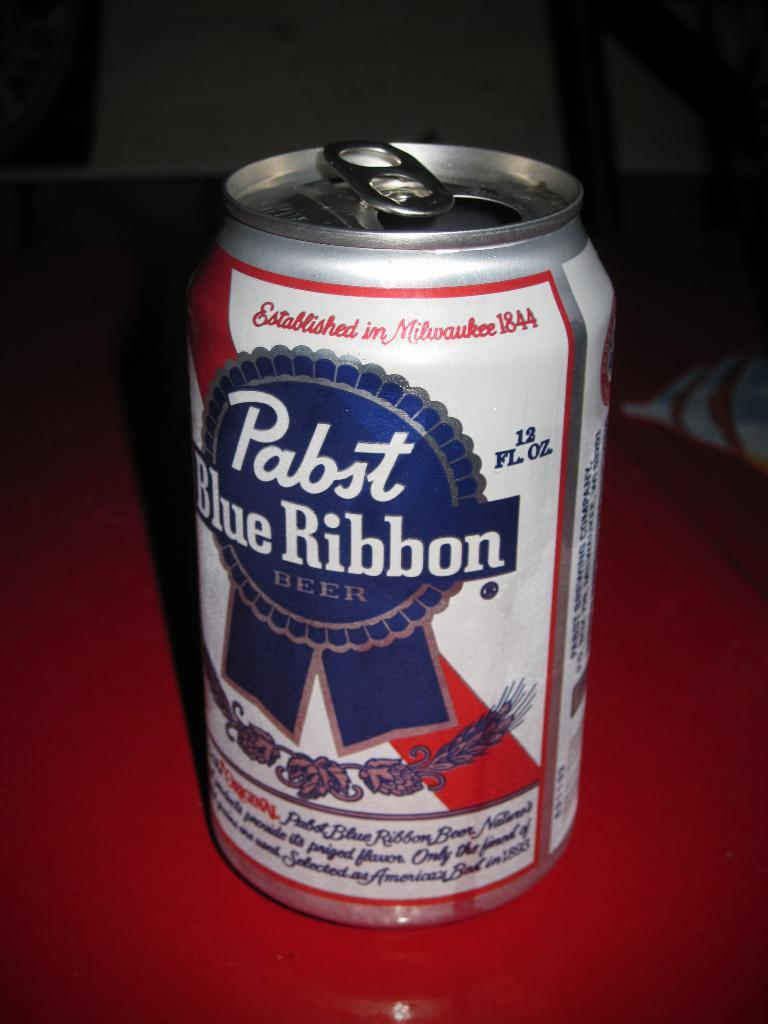What object is visible in the image? There is a juice can in the image. Where is the juice can located? The juice can is placed on a table. What type of skirt is hanging on the wall in the image? There is no skirt present in the image; it only features a juice can placed on a table. 